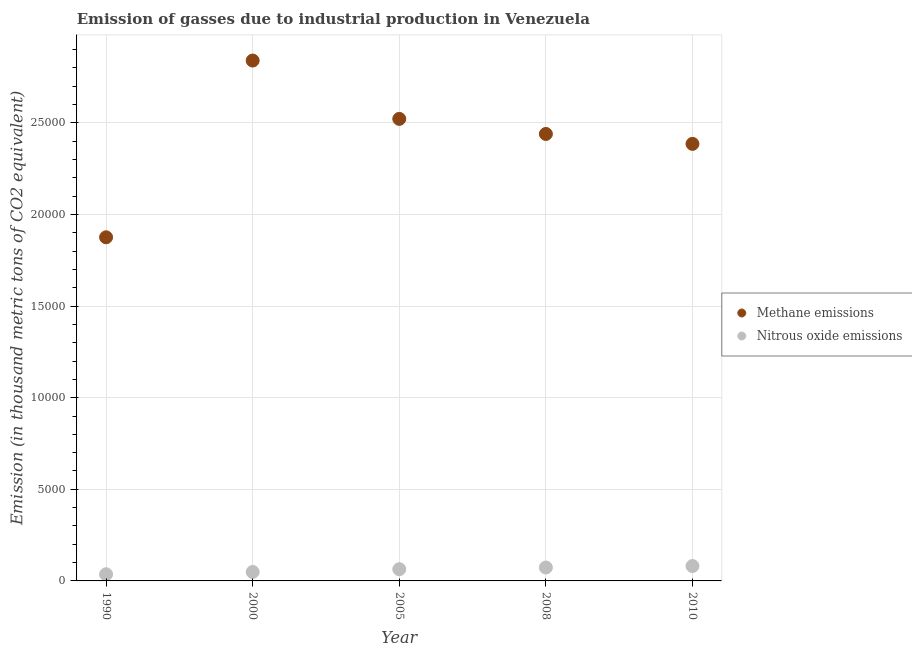How many different coloured dotlines are there?
Your answer should be very brief. 2. What is the amount of methane emissions in 2005?
Your answer should be very brief. 2.52e+04. Across all years, what is the maximum amount of methane emissions?
Provide a succinct answer. 2.84e+04. Across all years, what is the minimum amount of nitrous oxide emissions?
Offer a terse response. 363.6. In which year was the amount of nitrous oxide emissions minimum?
Provide a succinct answer. 1990. What is the total amount of nitrous oxide emissions in the graph?
Provide a short and direct response. 3035.5. What is the difference between the amount of nitrous oxide emissions in 2000 and that in 2005?
Provide a succinct answer. -149.8. What is the difference between the amount of nitrous oxide emissions in 2010 and the amount of methane emissions in 2008?
Make the answer very short. -2.36e+04. What is the average amount of methane emissions per year?
Your answer should be compact. 2.41e+04. In the year 2008, what is the difference between the amount of methane emissions and amount of nitrous oxide emissions?
Your response must be concise. 2.37e+04. What is the ratio of the amount of nitrous oxide emissions in 1990 to that in 2000?
Ensure brevity in your answer.  0.74. Is the difference between the amount of methane emissions in 2005 and 2008 greater than the difference between the amount of nitrous oxide emissions in 2005 and 2008?
Provide a short and direct response. Yes. What is the difference between the highest and the second highest amount of nitrous oxide emissions?
Keep it short and to the point. 80.3. What is the difference between the highest and the lowest amount of nitrous oxide emissions?
Your answer should be compact. 448.3. In how many years, is the amount of methane emissions greater than the average amount of methane emissions taken over all years?
Your answer should be compact. 3. Is the amount of nitrous oxide emissions strictly greater than the amount of methane emissions over the years?
Make the answer very short. No. Is the amount of methane emissions strictly less than the amount of nitrous oxide emissions over the years?
Keep it short and to the point. No. How many dotlines are there?
Your answer should be compact. 2. How many years are there in the graph?
Make the answer very short. 5. Are the values on the major ticks of Y-axis written in scientific E-notation?
Provide a short and direct response. No. Does the graph contain any zero values?
Make the answer very short. No. How are the legend labels stacked?
Ensure brevity in your answer.  Vertical. What is the title of the graph?
Give a very brief answer. Emission of gasses due to industrial production in Venezuela. What is the label or title of the Y-axis?
Provide a succinct answer. Emission (in thousand metric tons of CO2 equivalent). What is the Emission (in thousand metric tons of CO2 equivalent) of Methane emissions in 1990?
Offer a very short reply. 1.88e+04. What is the Emission (in thousand metric tons of CO2 equivalent) of Nitrous oxide emissions in 1990?
Your response must be concise. 363.6. What is the Emission (in thousand metric tons of CO2 equivalent) in Methane emissions in 2000?
Make the answer very short. 2.84e+04. What is the Emission (in thousand metric tons of CO2 equivalent) in Nitrous oxide emissions in 2000?
Offer a very short reply. 489.3. What is the Emission (in thousand metric tons of CO2 equivalent) of Methane emissions in 2005?
Your answer should be compact. 2.52e+04. What is the Emission (in thousand metric tons of CO2 equivalent) of Nitrous oxide emissions in 2005?
Make the answer very short. 639.1. What is the Emission (in thousand metric tons of CO2 equivalent) of Methane emissions in 2008?
Offer a very short reply. 2.44e+04. What is the Emission (in thousand metric tons of CO2 equivalent) in Nitrous oxide emissions in 2008?
Provide a short and direct response. 731.6. What is the Emission (in thousand metric tons of CO2 equivalent) of Methane emissions in 2010?
Your answer should be very brief. 2.39e+04. What is the Emission (in thousand metric tons of CO2 equivalent) in Nitrous oxide emissions in 2010?
Offer a terse response. 811.9. Across all years, what is the maximum Emission (in thousand metric tons of CO2 equivalent) of Methane emissions?
Ensure brevity in your answer.  2.84e+04. Across all years, what is the maximum Emission (in thousand metric tons of CO2 equivalent) of Nitrous oxide emissions?
Make the answer very short. 811.9. Across all years, what is the minimum Emission (in thousand metric tons of CO2 equivalent) of Methane emissions?
Provide a succinct answer. 1.88e+04. Across all years, what is the minimum Emission (in thousand metric tons of CO2 equivalent) of Nitrous oxide emissions?
Give a very brief answer. 363.6. What is the total Emission (in thousand metric tons of CO2 equivalent) of Methane emissions in the graph?
Keep it short and to the point. 1.21e+05. What is the total Emission (in thousand metric tons of CO2 equivalent) of Nitrous oxide emissions in the graph?
Keep it short and to the point. 3035.5. What is the difference between the Emission (in thousand metric tons of CO2 equivalent) of Methane emissions in 1990 and that in 2000?
Ensure brevity in your answer.  -9645.4. What is the difference between the Emission (in thousand metric tons of CO2 equivalent) in Nitrous oxide emissions in 1990 and that in 2000?
Your answer should be compact. -125.7. What is the difference between the Emission (in thousand metric tons of CO2 equivalent) in Methane emissions in 1990 and that in 2005?
Your response must be concise. -6462.5. What is the difference between the Emission (in thousand metric tons of CO2 equivalent) in Nitrous oxide emissions in 1990 and that in 2005?
Your answer should be very brief. -275.5. What is the difference between the Emission (in thousand metric tons of CO2 equivalent) in Methane emissions in 1990 and that in 2008?
Offer a very short reply. -5639.8. What is the difference between the Emission (in thousand metric tons of CO2 equivalent) in Nitrous oxide emissions in 1990 and that in 2008?
Provide a short and direct response. -368. What is the difference between the Emission (in thousand metric tons of CO2 equivalent) of Methane emissions in 1990 and that in 2010?
Your answer should be very brief. -5098.4. What is the difference between the Emission (in thousand metric tons of CO2 equivalent) of Nitrous oxide emissions in 1990 and that in 2010?
Provide a short and direct response. -448.3. What is the difference between the Emission (in thousand metric tons of CO2 equivalent) of Methane emissions in 2000 and that in 2005?
Give a very brief answer. 3182.9. What is the difference between the Emission (in thousand metric tons of CO2 equivalent) in Nitrous oxide emissions in 2000 and that in 2005?
Provide a short and direct response. -149.8. What is the difference between the Emission (in thousand metric tons of CO2 equivalent) of Methane emissions in 2000 and that in 2008?
Your answer should be compact. 4005.6. What is the difference between the Emission (in thousand metric tons of CO2 equivalent) of Nitrous oxide emissions in 2000 and that in 2008?
Provide a short and direct response. -242.3. What is the difference between the Emission (in thousand metric tons of CO2 equivalent) in Methane emissions in 2000 and that in 2010?
Ensure brevity in your answer.  4547. What is the difference between the Emission (in thousand metric tons of CO2 equivalent) of Nitrous oxide emissions in 2000 and that in 2010?
Your response must be concise. -322.6. What is the difference between the Emission (in thousand metric tons of CO2 equivalent) of Methane emissions in 2005 and that in 2008?
Your answer should be compact. 822.7. What is the difference between the Emission (in thousand metric tons of CO2 equivalent) of Nitrous oxide emissions in 2005 and that in 2008?
Give a very brief answer. -92.5. What is the difference between the Emission (in thousand metric tons of CO2 equivalent) of Methane emissions in 2005 and that in 2010?
Your answer should be very brief. 1364.1. What is the difference between the Emission (in thousand metric tons of CO2 equivalent) in Nitrous oxide emissions in 2005 and that in 2010?
Provide a succinct answer. -172.8. What is the difference between the Emission (in thousand metric tons of CO2 equivalent) in Methane emissions in 2008 and that in 2010?
Make the answer very short. 541.4. What is the difference between the Emission (in thousand metric tons of CO2 equivalent) in Nitrous oxide emissions in 2008 and that in 2010?
Provide a succinct answer. -80.3. What is the difference between the Emission (in thousand metric tons of CO2 equivalent) of Methane emissions in 1990 and the Emission (in thousand metric tons of CO2 equivalent) of Nitrous oxide emissions in 2000?
Offer a very short reply. 1.83e+04. What is the difference between the Emission (in thousand metric tons of CO2 equivalent) of Methane emissions in 1990 and the Emission (in thousand metric tons of CO2 equivalent) of Nitrous oxide emissions in 2005?
Make the answer very short. 1.81e+04. What is the difference between the Emission (in thousand metric tons of CO2 equivalent) of Methane emissions in 1990 and the Emission (in thousand metric tons of CO2 equivalent) of Nitrous oxide emissions in 2008?
Keep it short and to the point. 1.80e+04. What is the difference between the Emission (in thousand metric tons of CO2 equivalent) of Methane emissions in 1990 and the Emission (in thousand metric tons of CO2 equivalent) of Nitrous oxide emissions in 2010?
Provide a succinct answer. 1.79e+04. What is the difference between the Emission (in thousand metric tons of CO2 equivalent) of Methane emissions in 2000 and the Emission (in thousand metric tons of CO2 equivalent) of Nitrous oxide emissions in 2005?
Provide a succinct answer. 2.78e+04. What is the difference between the Emission (in thousand metric tons of CO2 equivalent) in Methane emissions in 2000 and the Emission (in thousand metric tons of CO2 equivalent) in Nitrous oxide emissions in 2008?
Offer a very short reply. 2.77e+04. What is the difference between the Emission (in thousand metric tons of CO2 equivalent) in Methane emissions in 2000 and the Emission (in thousand metric tons of CO2 equivalent) in Nitrous oxide emissions in 2010?
Give a very brief answer. 2.76e+04. What is the difference between the Emission (in thousand metric tons of CO2 equivalent) of Methane emissions in 2005 and the Emission (in thousand metric tons of CO2 equivalent) of Nitrous oxide emissions in 2008?
Ensure brevity in your answer.  2.45e+04. What is the difference between the Emission (in thousand metric tons of CO2 equivalent) in Methane emissions in 2005 and the Emission (in thousand metric tons of CO2 equivalent) in Nitrous oxide emissions in 2010?
Provide a succinct answer. 2.44e+04. What is the difference between the Emission (in thousand metric tons of CO2 equivalent) in Methane emissions in 2008 and the Emission (in thousand metric tons of CO2 equivalent) in Nitrous oxide emissions in 2010?
Your response must be concise. 2.36e+04. What is the average Emission (in thousand metric tons of CO2 equivalent) in Methane emissions per year?
Provide a succinct answer. 2.41e+04. What is the average Emission (in thousand metric tons of CO2 equivalent) in Nitrous oxide emissions per year?
Make the answer very short. 607.1. In the year 1990, what is the difference between the Emission (in thousand metric tons of CO2 equivalent) of Methane emissions and Emission (in thousand metric tons of CO2 equivalent) of Nitrous oxide emissions?
Your answer should be compact. 1.84e+04. In the year 2000, what is the difference between the Emission (in thousand metric tons of CO2 equivalent) of Methane emissions and Emission (in thousand metric tons of CO2 equivalent) of Nitrous oxide emissions?
Make the answer very short. 2.79e+04. In the year 2005, what is the difference between the Emission (in thousand metric tons of CO2 equivalent) in Methane emissions and Emission (in thousand metric tons of CO2 equivalent) in Nitrous oxide emissions?
Your response must be concise. 2.46e+04. In the year 2008, what is the difference between the Emission (in thousand metric tons of CO2 equivalent) of Methane emissions and Emission (in thousand metric tons of CO2 equivalent) of Nitrous oxide emissions?
Keep it short and to the point. 2.37e+04. In the year 2010, what is the difference between the Emission (in thousand metric tons of CO2 equivalent) in Methane emissions and Emission (in thousand metric tons of CO2 equivalent) in Nitrous oxide emissions?
Provide a succinct answer. 2.30e+04. What is the ratio of the Emission (in thousand metric tons of CO2 equivalent) in Methane emissions in 1990 to that in 2000?
Your answer should be compact. 0.66. What is the ratio of the Emission (in thousand metric tons of CO2 equivalent) of Nitrous oxide emissions in 1990 to that in 2000?
Your answer should be compact. 0.74. What is the ratio of the Emission (in thousand metric tons of CO2 equivalent) in Methane emissions in 1990 to that in 2005?
Your response must be concise. 0.74. What is the ratio of the Emission (in thousand metric tons of CO2 equivalent) of Nitrous oxide emissions in 1990 to that in 2005?
Your answer should be compact. 0.57. What is the ratio of the Emission (in thousand metric tons of CO2 equivalent) of Methane emissions in 1990 to that in 2008?
Offer a very short reply. 0.77. What is the ratio of the Emission (in thousand metric tons of CO2 equivalent) of Nitrous oxide emissions in 1990 to that in 2008?
Ensure brevity in your answer.  0.5. What is the ratio of the Emission (in thousand metric tons of CO2 equivalent) of Methane emissions in 1990 to that in 2010?
Your answer should be compact. 0.79. What is the ratio of the Emission (in thousand metric tons of CO2 equivalent) in Nitrous oxide emissions in 1990 to that in 2010?
Your response must be concise. 0.45. What is the ratio of the Emission (in thousand metric tons of CO2 equivalent) in Methane emissions in 2000 to that in 2005?
Your response must be concise. 1.13. What is the ratio of the Emission (in thousand metric tons of CO2 equivalent) of Nitrous oxide emissions in 2000 to that in 2005?
Provide a short and direct response. 0.77. What is the ratio of the Emission (in thousand metric tons of CO2 equivalent) of Methane emissions in 2000 to that in 2008?
Keep it short and to the point. 1.16. What is the ratio of the Emission (in thousand metric tons of CO2 equivalent) in Nitrous oxide emissions in 2000 to that in 2008?
Make the answer very short. 0.67. What is the ratio of the Emission (in thousand metric tons of CO2 equivalent) of Methane emissions in 2000 to that in 2010?
Offer a very short reply. 1.19. What is the ratio of the Emission (in thousand metric tons of CO2 equivalent) in Nitrous oxide emissions in 2000 to that in 2010?
Keep it short and to the point. 0.6. What is the ratio of the Emission (in thousand metric tons of CO2 equivalent) in Methane emissions in 2005 to that in 2008?
Give a very brief answer. 1.03. What is the ratio of the Emission (in thousand metric tons of CO2 equivalent) in Nitrous oxide emissions in 2005 to that in 2008?
Offer a terse response. 0.87. What is the ratio of the Emission (in thousand metric tons of CO2 equivalent) of Methane emissions in 2005 to that in 2010?
Provide a short and direct response. 1.06. What is the ratio of the Emission (in thousand metric tons of CO2 equivalent) of Nitrous oxide emissions in 2005 to that in 2010?
Keep it short and to the point. 0.79. What is the ratio of the Emission (in thousand metric tons of CO2 equivalent) in Methane emissions in 2008 to that in 2010?
Provide a short and direct response. 1.02. What is the ratio of the Emission (in thousand metric tons of CO2 equivalent) in Nitrous oxide emissions in 2008 to that in 2010?
Provide a succinct answer. 0.9. What is the difference between the highest and the second highest Emission (in thousand metric tons of CO2 equivalent) in Methane emissions?
Keep it short and to the point. 3182.9. What is the difference between the highest and the second highest Emission (in thousand metric tons of CO2 equivalent) of Nitrous oxide emissions?
Your answer should be very brief. 80.3. What is the difference between the highest and the lowest Emission (in thousand metric tons of CO2 equivalent) in Methane emissions?
Provide a succinct answer. 9645.4. What is the difference between the highest and the lowest Emission (in thousand metric tons of CO2 equivalent) of Nitrous oxide emissions?
Ensure brevity in your answer.  448.3. 